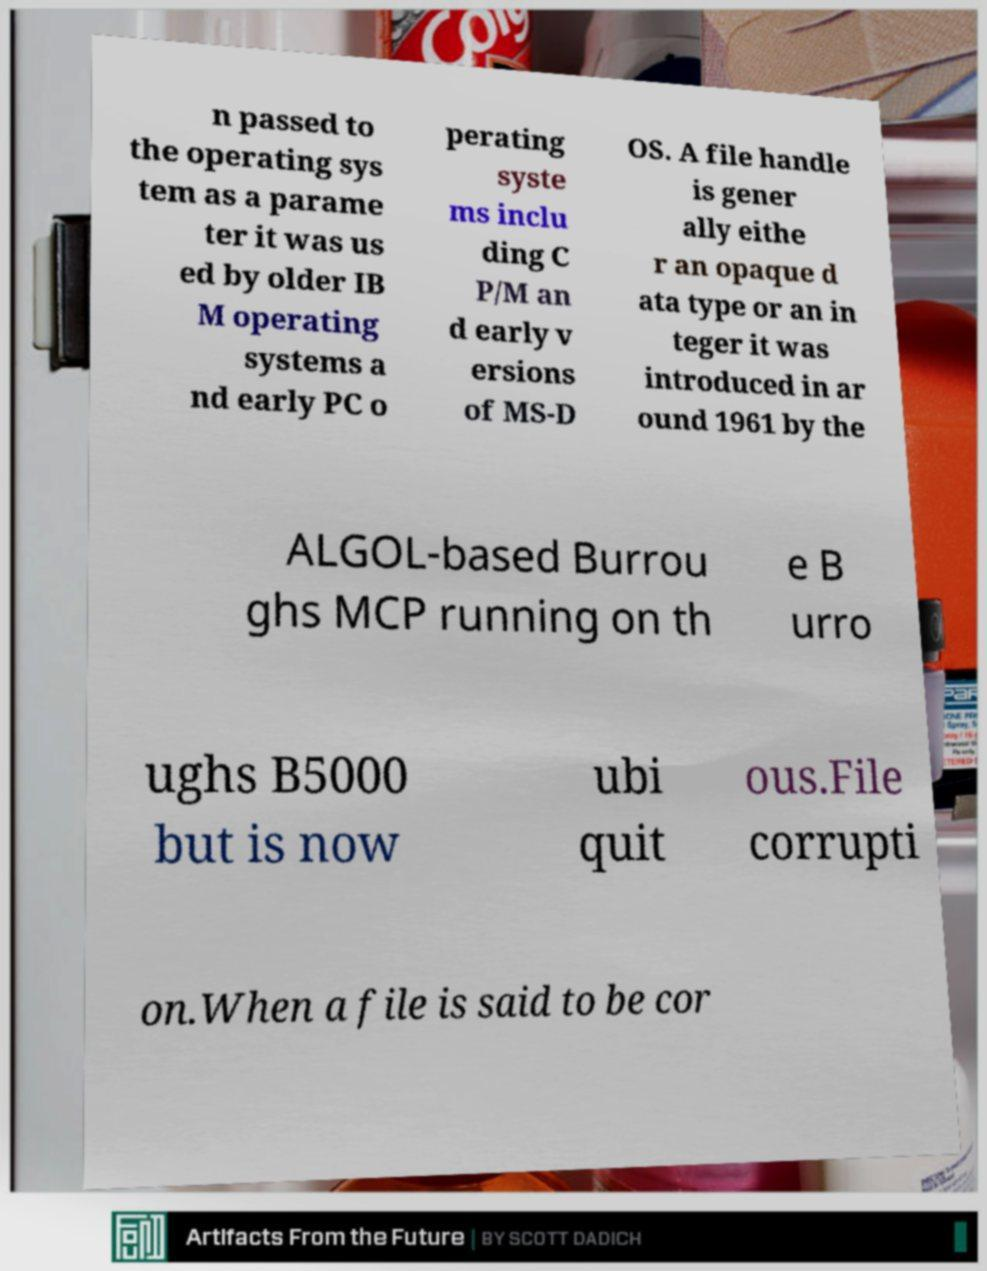For documentation purposes, I need the text within this image transcribed. Could you provide that? n passed to the operating sys tem as a parame ter it was us ed by older IB M operating systems a nd early PC o perating syste ms inclu ding C P/M an d early v ersions of MS-D OS. A file handle is gener ally eithe r an opaque d ata type or an in teger it was introduced in ar ound 1961 by the ALGOL-based Burrou ghs MCP running on th e B urro ughs B5000 but is now ubi quit ous.File corrupti on.When a file is said to be cor 